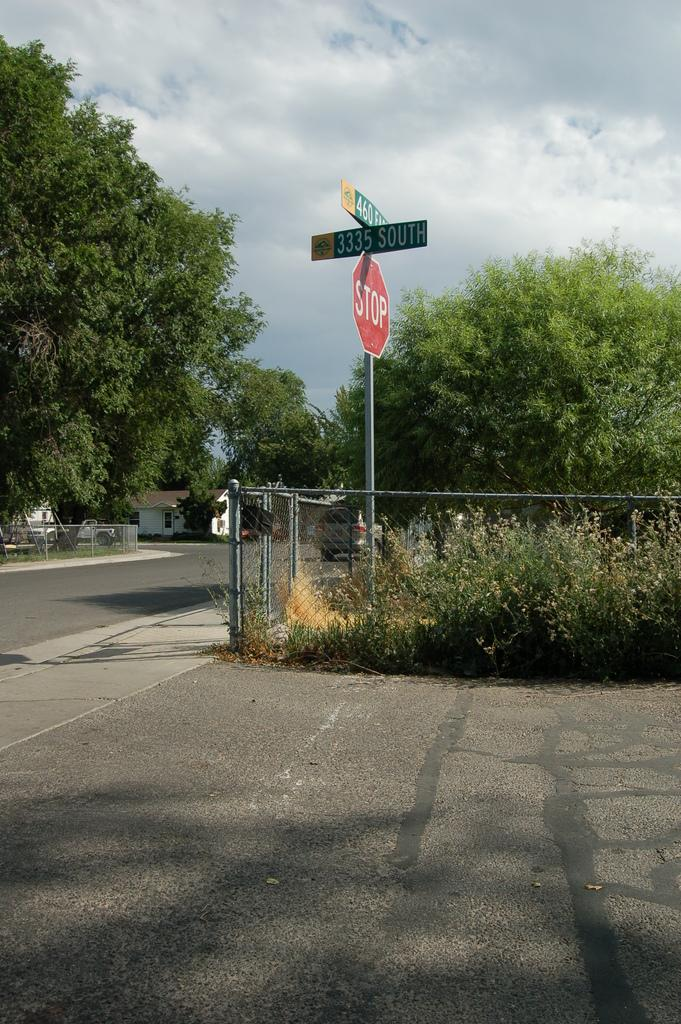What type of location is depicted in the image? There is a street road in the image. What can be seen around the street road? Trees and plants are present around the street road. What type of information might be conveyed by the sign boards in the image? The sign boards in the image might convey information about directions, warnings, or advertisements. What is the color of the sky in the image? The sky is blue in the image. What type of brain activity can be observed in the image? There is no brain present in the image, so it is not possible to observe any brain activity. 